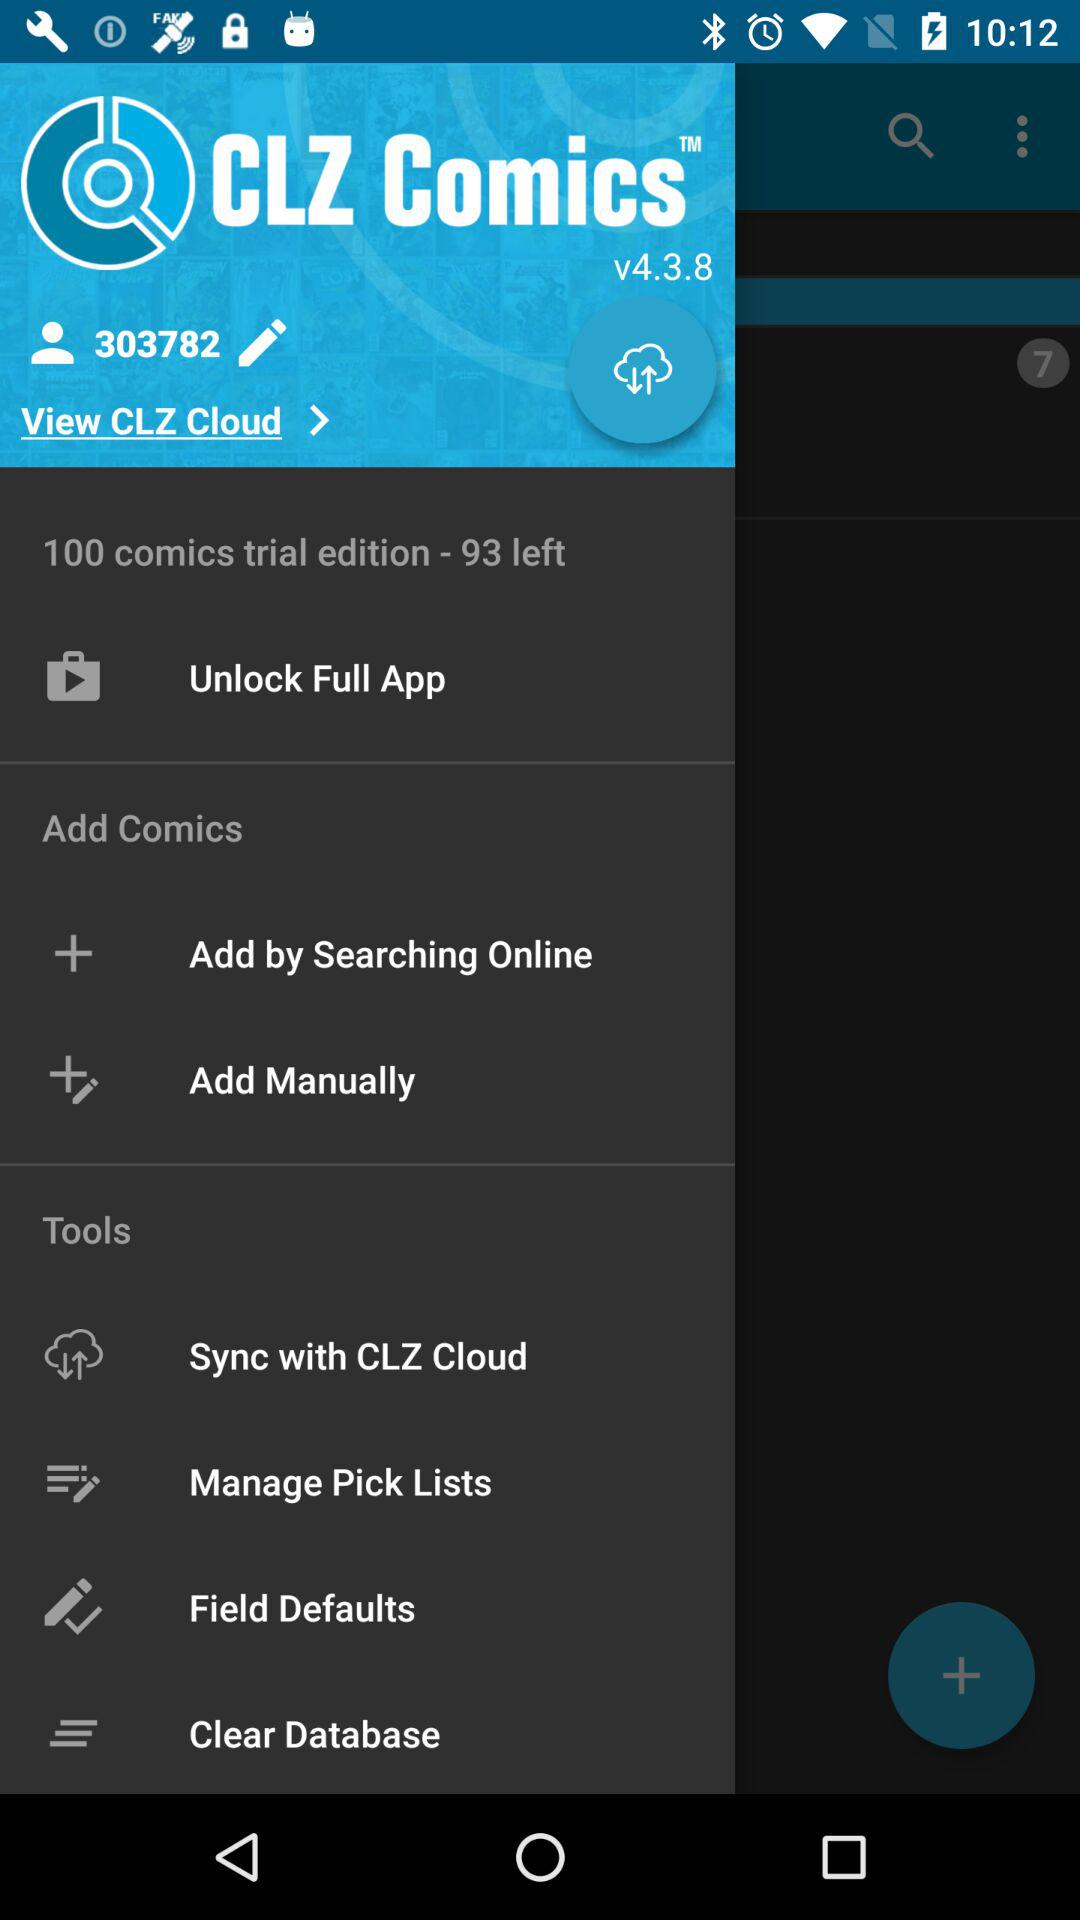How many comics are left in the "100 comics trial edition"? There are 93 comics left. 